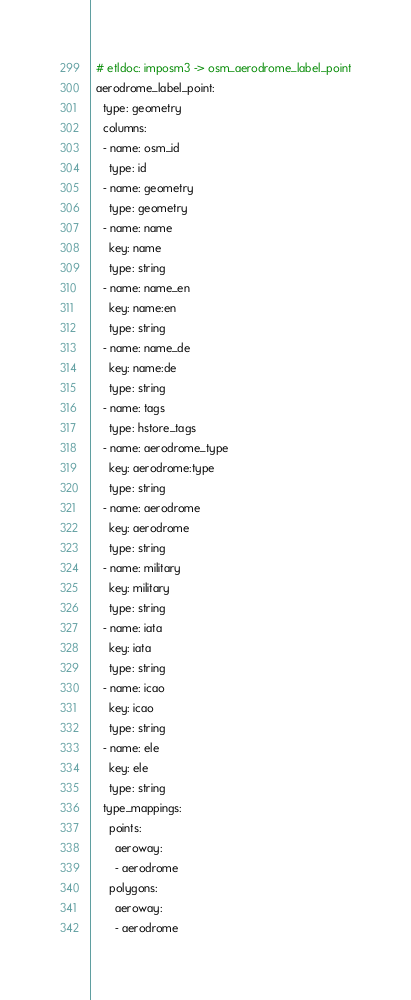<code> <loc_0><loc_0><loc_500><loc_500><_YAML_>  # etldoc: imposm3 -> osm_aerodrome_label_point
  aerodrome_label_point:
    type: geometry
    columns:
    - name: osm_id
      type: id
    - name: geometry
      type: geometry
    - name: name
      key: name
      type: string
    - name: name_en
      key: name:en
      type: string
    - name: name_de
      key: name:de
      type: string
    - name: tags
      type: hstore_tags
    - name: aerodrome_type
      key: aerodrome:type
      type: string
    - name: aerodrome
      key: aerodrome
      type: string
    - name: military
      key: military
      type: string
    - name: iata
      key: iata
      type: string
    - name: icao
      key: icao
      type: string
    - name: ele
      key: ele
      type: string
    type_mappings:
      points:
        aeroway:
        - aerodrome
      polygons:
        aeroway:
        - aerodrome
</code> 